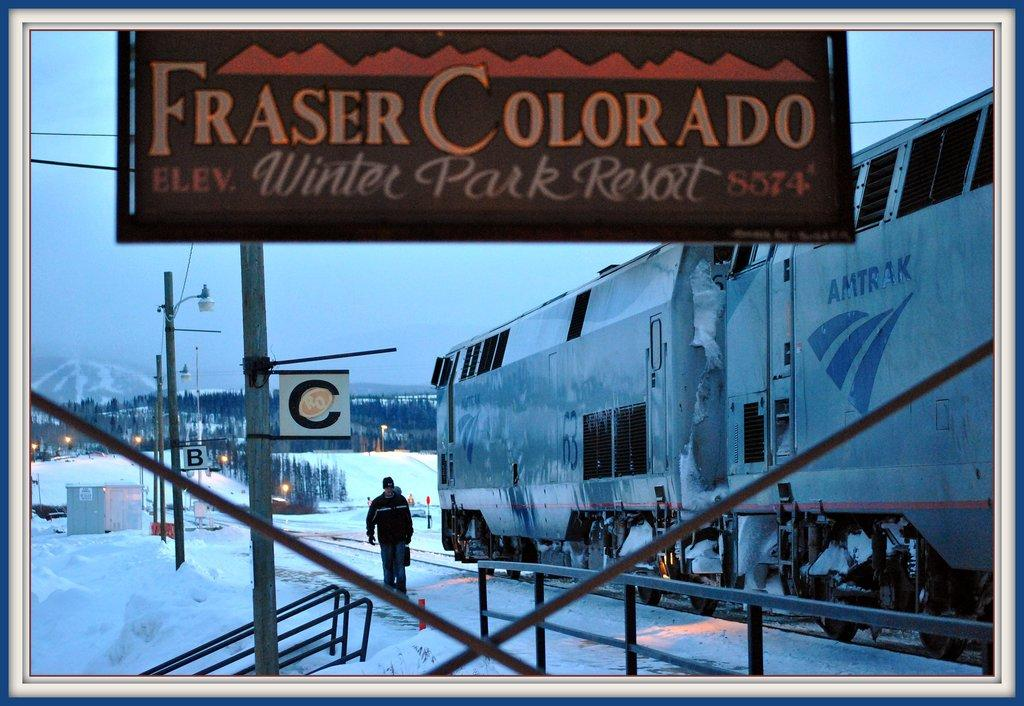<image>
Give a short and clear explanation of the subsequent image. A sign states that Winter Park Resort is in Fraser Colorado. 